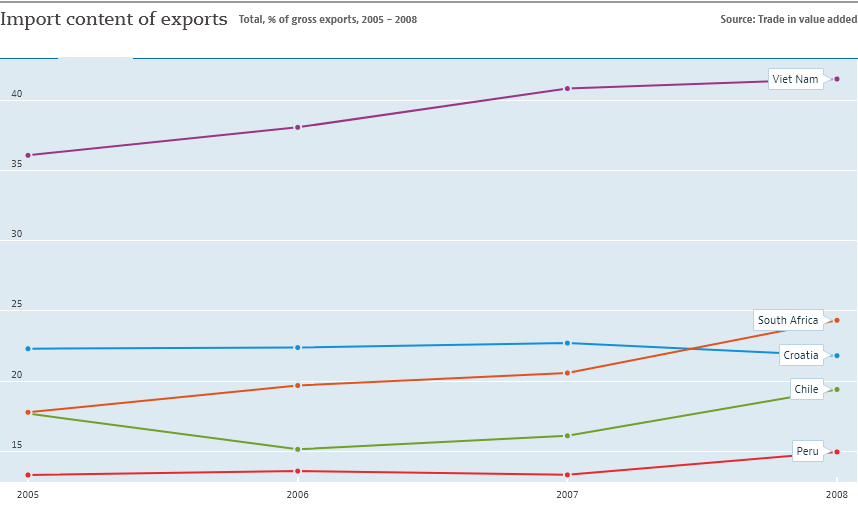Highlight a few significant elements in this photo. In 2008, Vietnam recorded the highest level of exports among all years in its history. In the given years, there were three counties whose exports were more than 20% of their overall value. 